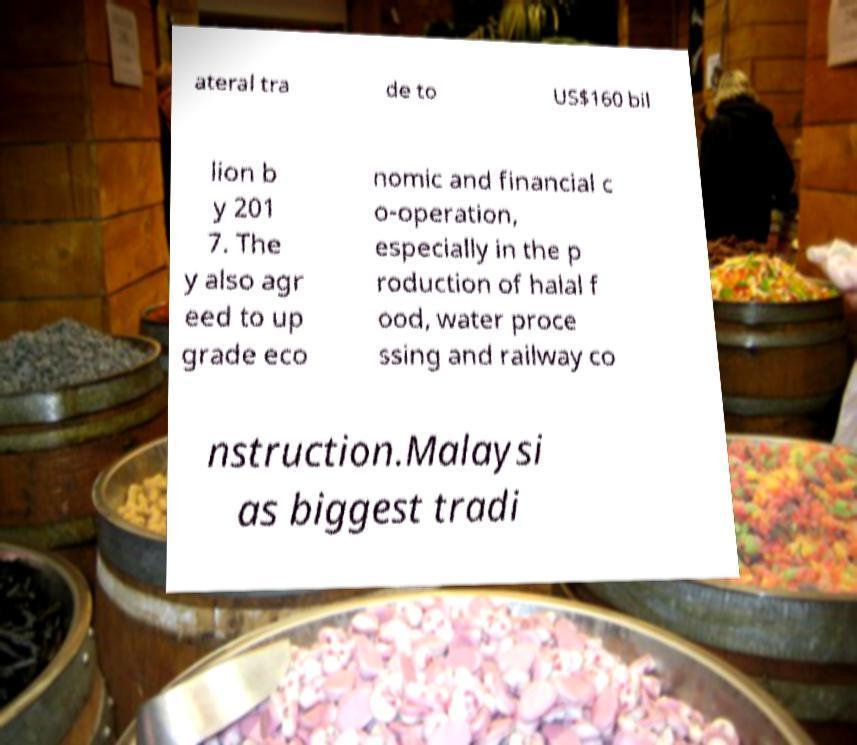For documentation purposes, I need the text within this image transcribed. Could you provide that? ateral tra de to US$160 bil lion b y 201 7. The y also agr eed to up grade eco nomic and financial c o-operation, especially in the p roduction of halal f ood, water proce ssing and railway co nstruction.Malaysi as biggest tradi 